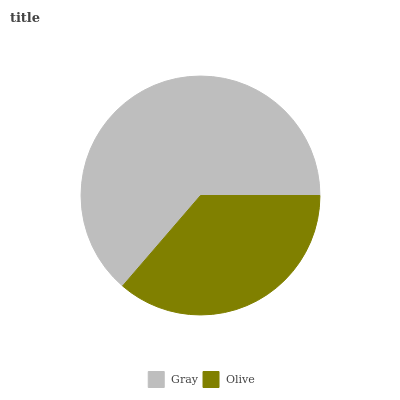Is Olive the minimum?
Answer yes or no. Yes. Is Gray the maximum?
Answer yes or no. Yes. Is Olive the maximum?
Answer yes or no. No. Is Gray greater than Olive?
Answer yes or no. Yes. Is Olive less than Gray?
Answer yes or no. Yes. Is Olive greater than Gray?
Answer yes or no. No. Is Gray less than Olive?
Answer yes or no. No. Is Gray the high median?
Answer yes or no. Yes. Is Olive the low median?
Answer yes or no. Yes. Is Olive the high median?
Answer yes or no. No. Is Gray the low median?
Answer yes or no. No. 